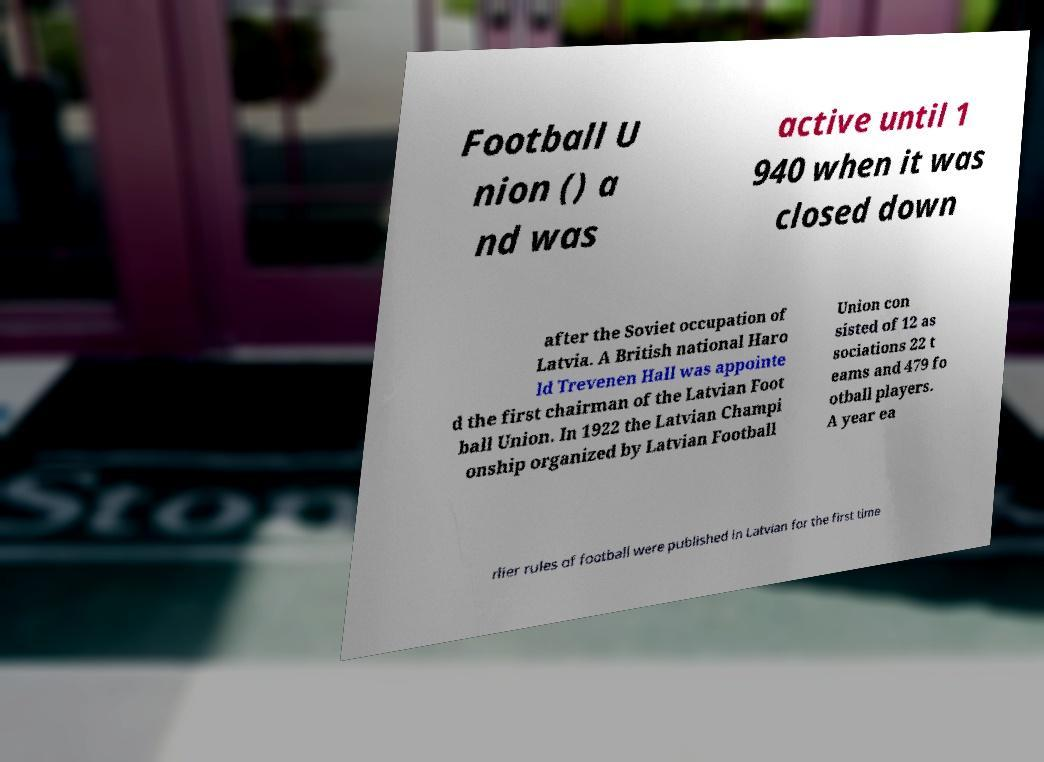Please read and relay the text visible in this image. What does it say? Football U nion () a nd was active until 1 940 when it was closed down after the Soviet occupation of Latvia. A British national Haro ld Trevenen Hall was appointe d the first chairman of the Latvian Foot ball Union. In 1922 the Latvian Champi onship organized by Latvian Football Union con sisted of 12 as sociations 22 t eams and 479 fo otball players. A year ea rlier rules of football were published in Latvian for the first time 